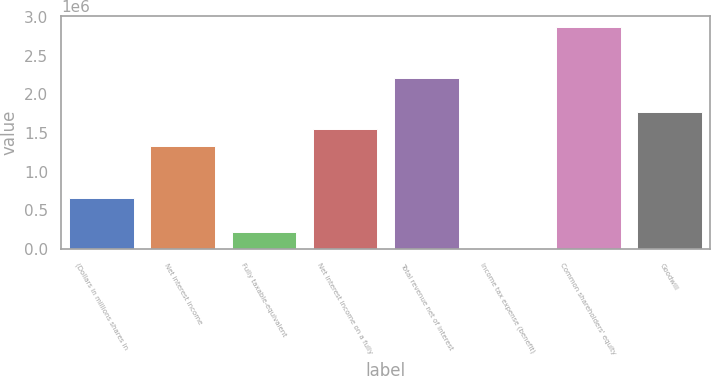<chart> <loc_0><loc_0><loc_500><loc_500><bar_chart><fcel>(Dollars in millions shares in<fcel>Net interest income<fcel>Fully taxable-equivalent<fcel>Net interest income on a fully<fcel>Total revenue net of interest<fcel>Income tax expense (benefit)<fcel>Common shareholders' equity<fcel>Goodwill<nl><fcel>663288<fcel>1.32616e+06<fcel>221375<fcel>1.54711e+06<fcel>2.20998e+06<fcel>419<fcel>2.87285e+06<fcel>1.76807e+06<nl></chart> 